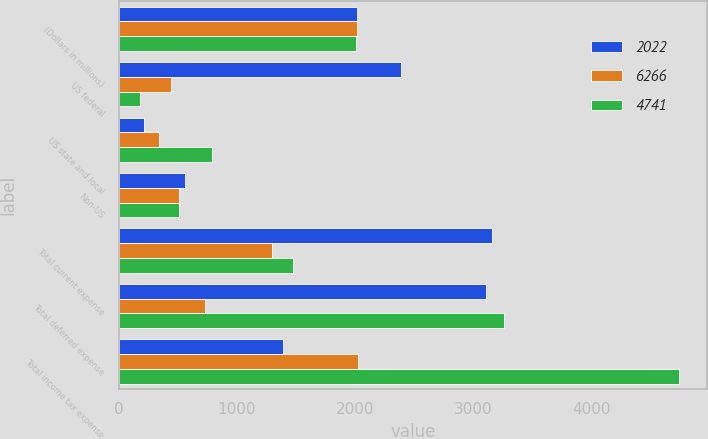Convert chart to OTSL. <chart><loc_0><loc_0><loc_500><loc_500><stacked_bar_chart><ecel><fcel>(Dollars in millions)<fcel>US federal<fcel>US state and local<fcel>Non-US<fcel>Total current expense<fcel>Total deferred expense<fcel>Total income tax expense<nl><fcel>2022<fcel>2015<fcel>2387<fcel>210<fcel>561<fcel>3158<fcel>3108<fcel>1387.5<nl><fcel>6266<fcel>2014<fcel>443<fcel>340<fcel>513<fcel>1296<fcel>726<fcel>2022<nl><fcel>4741<fcel>2013<fcel>180<fcel>786<fcel>513<fcel>1479<fcel>3262<fcel>4741<nl></chart> 